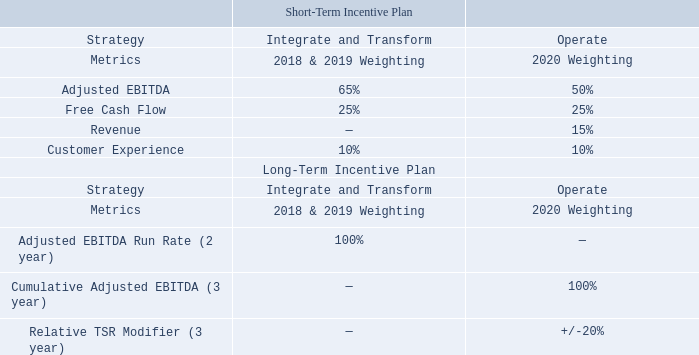2020 Incentive Plan Enhancements.
For 2020, we have transitioned into the operation phase of our long-term strategy. As discussed further in this
CD&A, following an internal review process, extensive discussions with our shareholders and consultation with our executive compensation consultants, we revised the design for our 2020 incentive programs to support our strategic priorities as described below:
• added Revenue as metric to our STI plan to encourage and reward top-line performance • changed the metric and performance period for our LTI plan to three-year cumulative Adjusted EBITDA target • added three-year Relative TSR Modifier, as a positive or negative adjustment +/- 20%, for our LTI plan.
Which metric was added under the Short-Term Incentive Plan for the 2020 incentive programs? Revenue. Why was Revenue added as a metric to the STI plan? To encourage and reward top-line performance. Which metrics were added under the Long-Term Incentive Plan Cumulative adjusted ebitda (3 year), relative tsr modifier (3 year). How many metrics were added under the Long-Term Incentive Plan? Cumulative Adjusted EBITDA (3 year)##Relative TSR Modifier (3 year)
Answer: 2. What is the  change in the Adjusted EBITDA target under Short-Term Incentive Plan in 2020?
Answer scale should be: percent. 65%-50%
Answer: 15. What is the average Adjusted EBITDA under the Short-Term Incentive Plan?
Answer scale should be: percent. (65%+50%)/2
Answer: 57.5. 